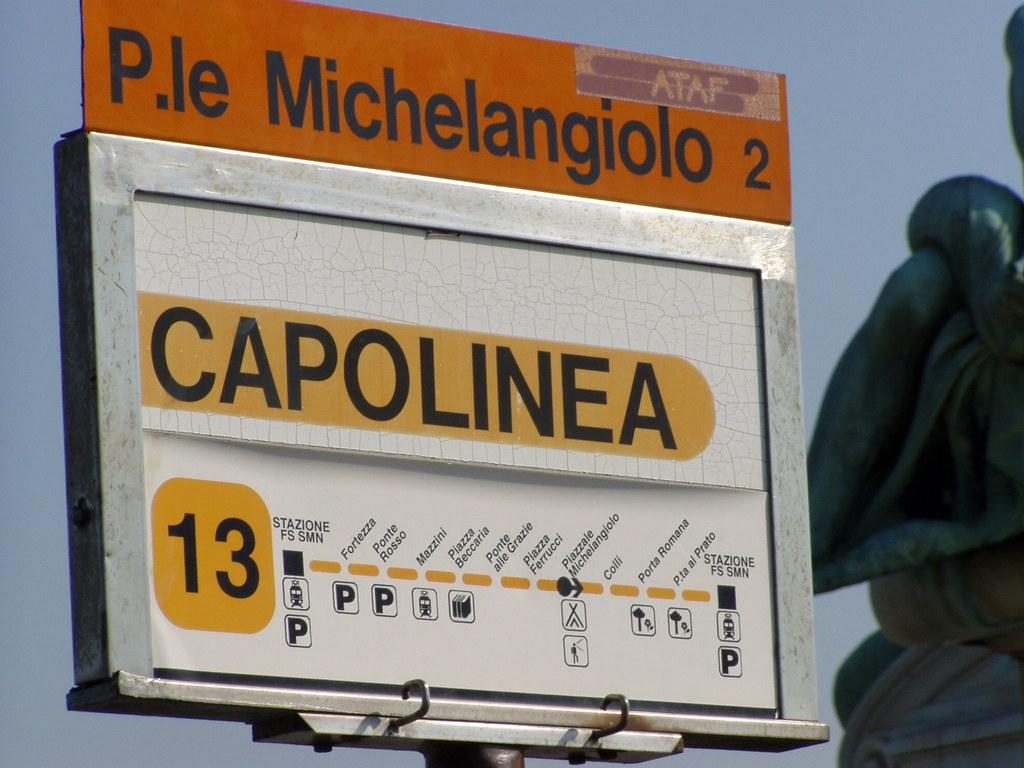<image>
Provide a brief description of the given image. The number 13 bus stop at Capolinea near P.le Michelangiolo 